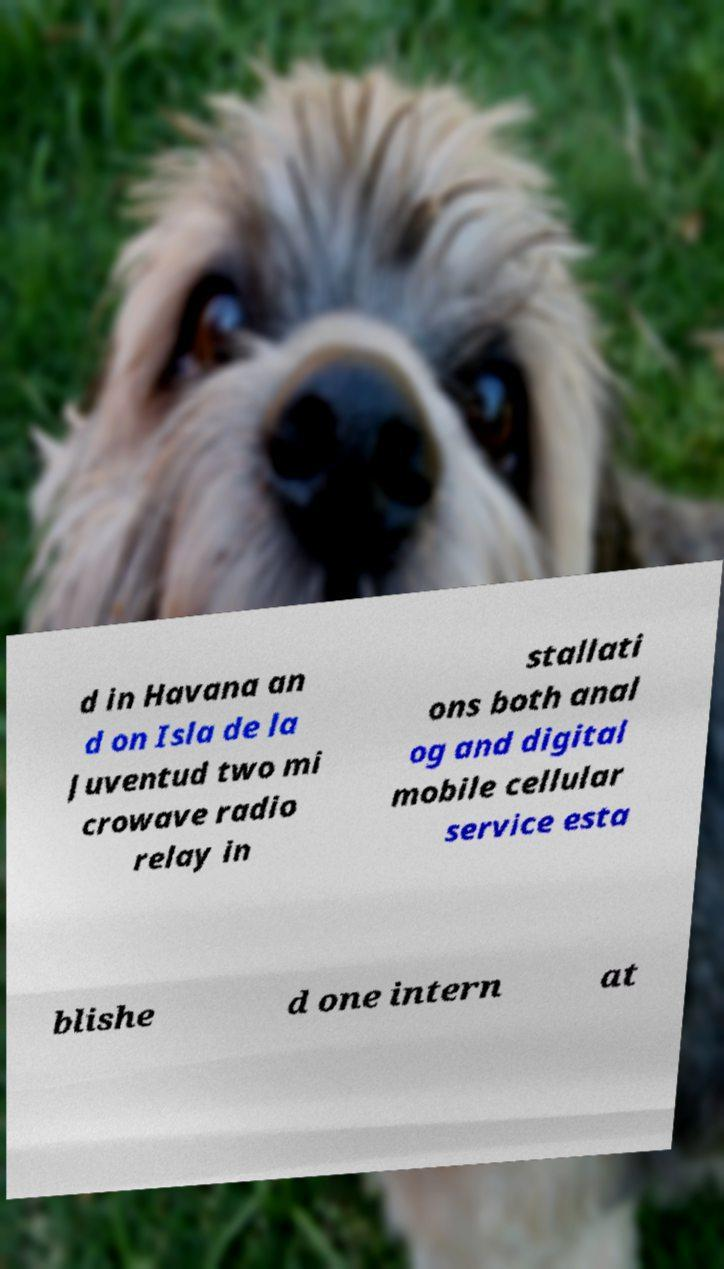I need the written content from this picture converted into text. Can you do that? d in Havana an d on Isla de la Juventud two mi crowave radio relay in stallati ons both anal og and digital mobile cellular service esta blishe d one intern at 